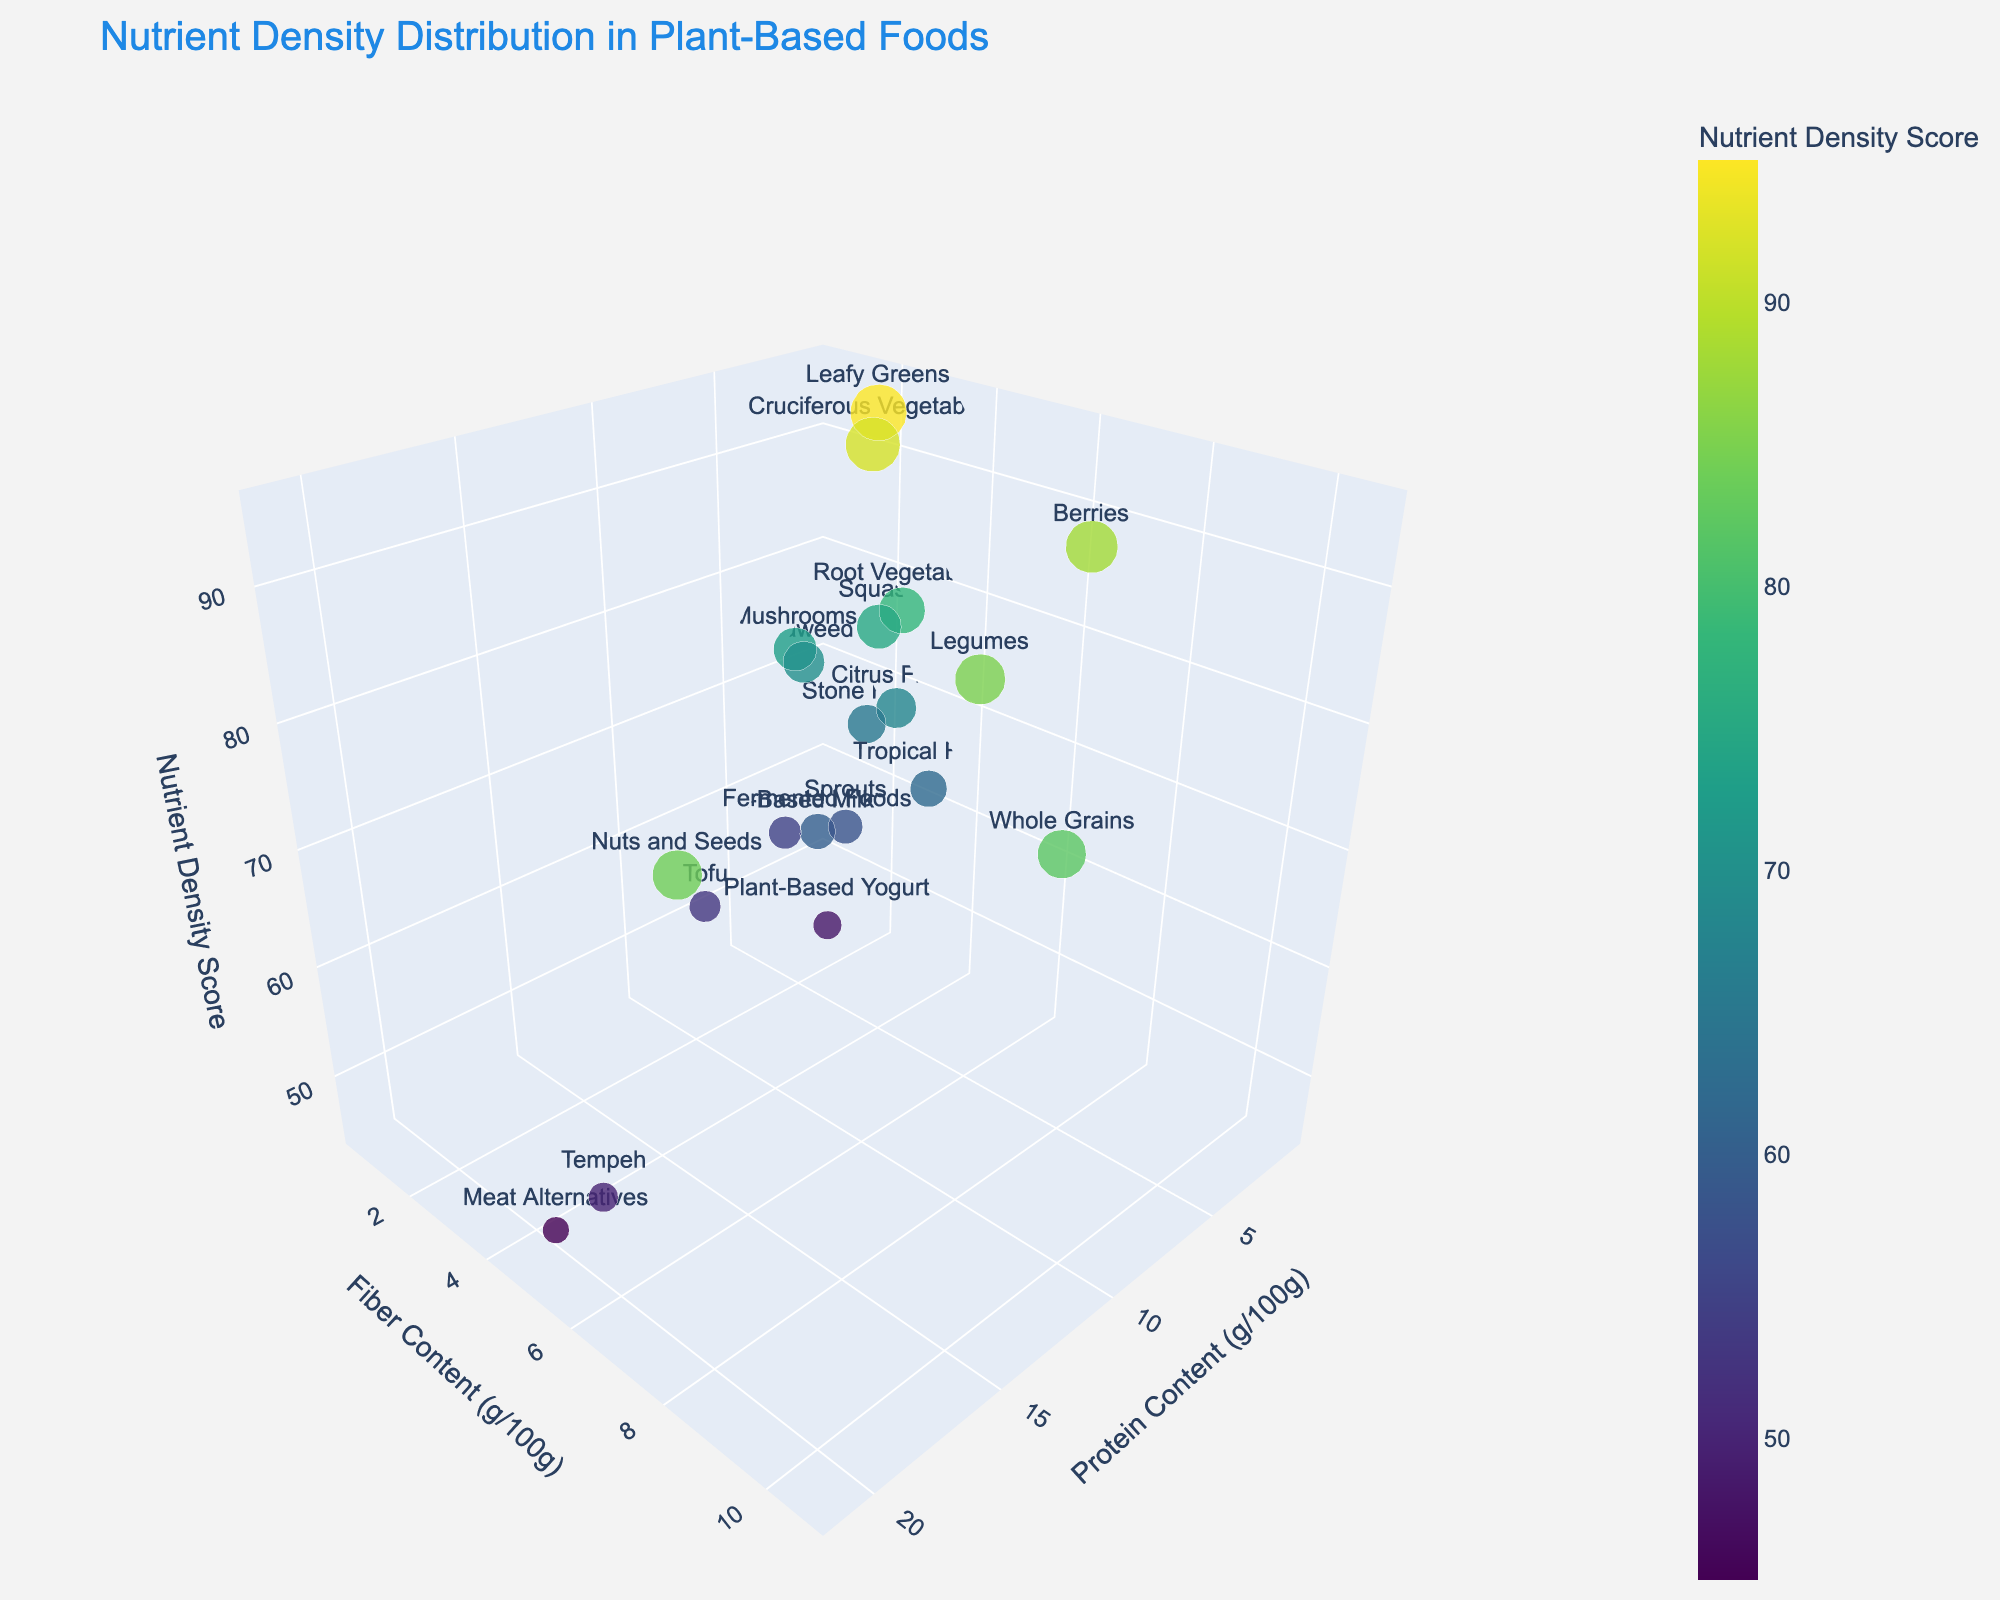What's the title of the figure? The title is clearly displayed at the top center of the plot, which states the main focus of the visualization.
Answer: Nutrient Density Distribution in Plant-Based Foods What does the z-axis represent in the plot? The axis labels in the plot clearly indicate what each axis represents. The z-axis label specifies that it shows the Nutrient Density Score.
Answer: Nutrient Density Score Which food category has the highest protein content? By examining the x-axis, which represents protein content, you can identify the point with the highest value. The highest protein content is represented by the point for "Nuts and Seeds" positioned farthest along the x-axis.
Answer: Nuts and Seeds Among foods with higher fiber content, which one has a lower nutrient density score, Tempeh or Legumes? Compare the positions of the data points for Tempeh and Legumes along the y-axis (Fiber Content) and z-axis (Nutrient Density Score). Tempeh has lower z-axis value than Legumes.
Answer: Tempeh How many food categories have a nutrient density score above 80? Observe the z-axis and count the markers that are positioned above the 80 value mark on the z-axis. The food categories above this threshold are Leafy Greens, Cruciferous Vegetables, Berries, Legumes, Nuts and Seeds, and Whole Grains.
Answer: Six Which food category is nearest to the coordinate (3, 3, 70) in the plot? Look for the marker closest to the specified (3, 3, 70) coordinate. The closest one is "Mushrooms."
Answer: Mushrooms What is the average protein content of Legumes and Whole Grains? Find the points for Legumes and Whole Grains, note their x-axis values for protein content (9.0 for Legumes and 13.2 for Whole Grains), and calculate the average: (9.0 + 13.2) / 2.
Answer: 11.1 Which food category has the highest fiber content under 70 nutrient density score? Locate the data points below the 70 mark on the z-axis. Among these, identify the one with the highest y-axis value (fiber content). Seaweed is evidenced below 70 with lower fiber content than Stone Fruits, which is 3.3.
Answer: Tropical Fruits 